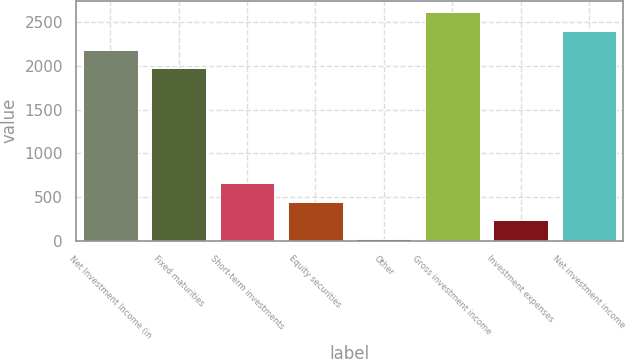Convert chart. <chart><loc_0><loc_0><loc_500><loc_500><bar_chart><fcel>Net Investment Income (in<fcel>Fixed maturities<fcel>Short-term investments<fcel>Equity securities<fcel>Other<fcel>Gross investment income<fcel>Investment expenses<fcel>Net investment income<nl><fcel>2185.4<fcel>1972<fcel>660.2<fcel>446.8<fcel>20<fcel>2612.2<fcel>233.4<fcel>2398.8<nl></chart> 